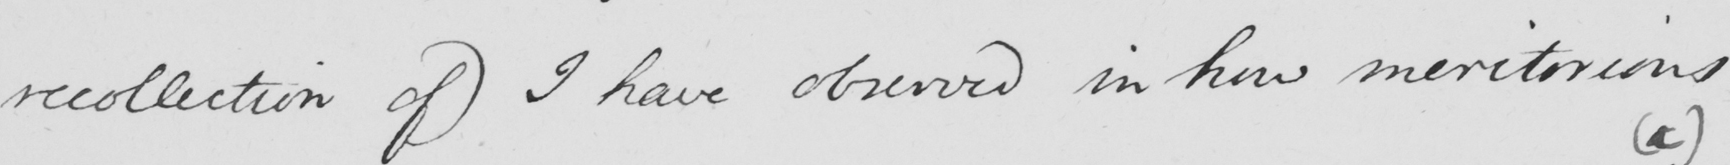Please transcribe the handwritten text in this image. recollection of )  I have observed in how meritorious 